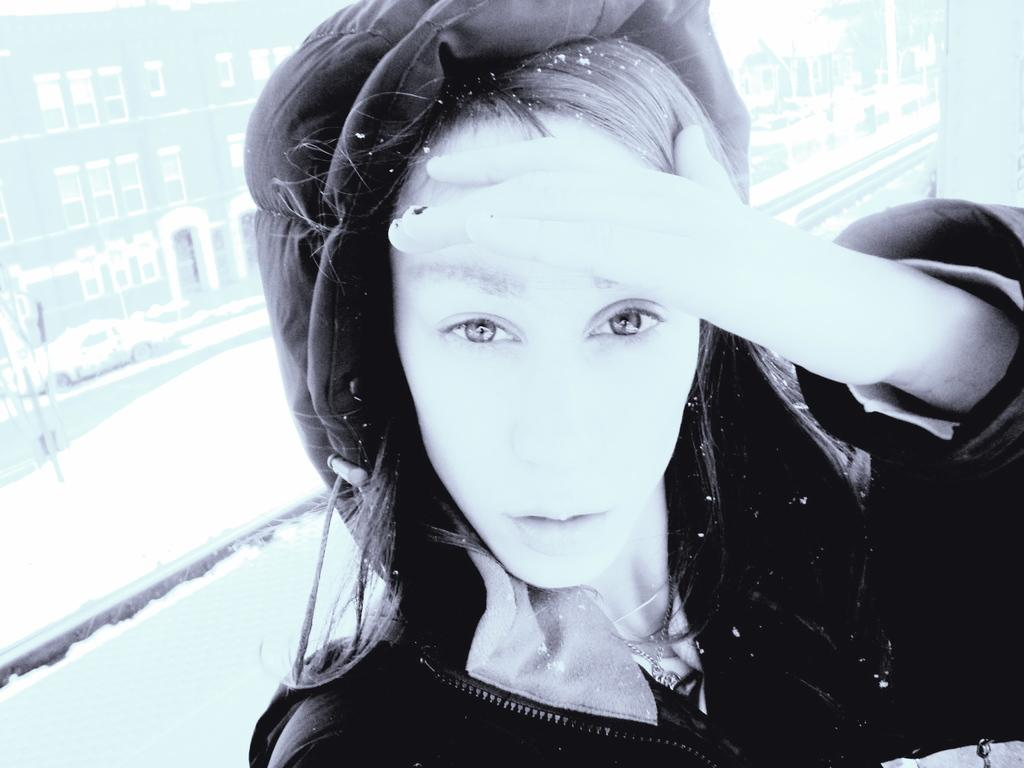Who or what is in the image? There is a person in the image. What is the ground like in the background? Snow is present on the ground in the background. What can be seen on the road in the background? There are vehicles on the road in the background. What type of structures are visible in the background? There are buildings in the background. What architectural features can be seen in the buildings? Windows and doors are visible in the background. What type of vegetation is present in the background? Trees are present in the background. What is the chance of winning an account in the image? There is no reference to winning an account or any gambling activity in the image. 